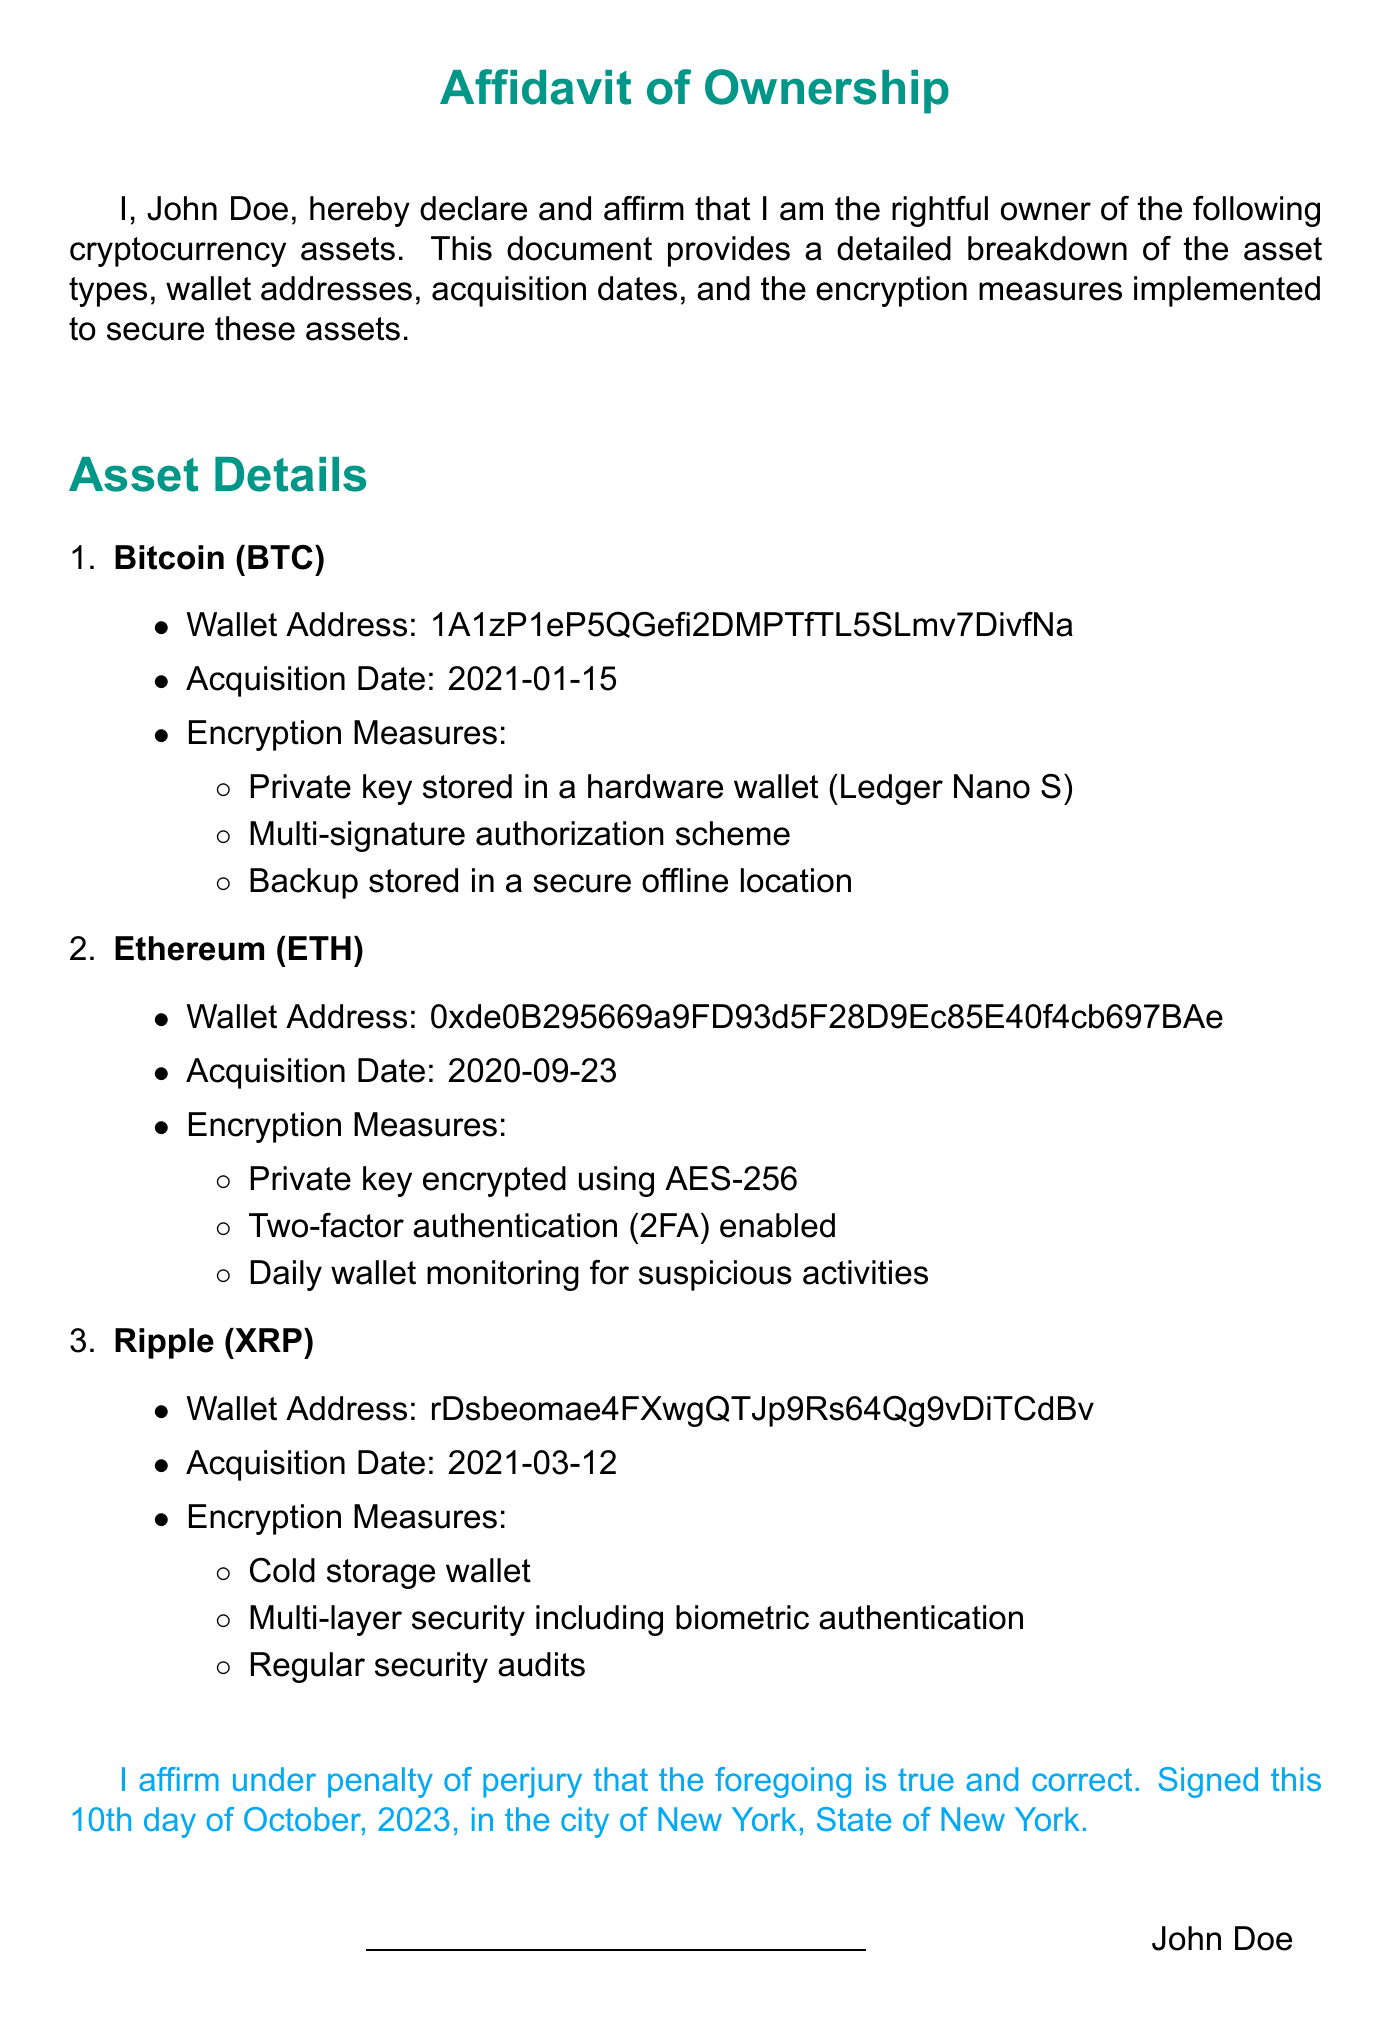What is the name of the owner? The owner's name is stated at the beginning of the document as "John Doe."
Answer: John Doe What cryptocurrency asset was acquired on 2021-01-15? This date corresponds to the acquisition of Bitcoin, as indicated in the asset details.
Answer: Bitcoin (BTC) What is the wallet address for Ethereum? The document specifies the Ethereum wallet address in the asset details section.
Answer: 0xde0B295669a9FD93d5F28D9Ec85E40f4cb697BAe What encryption measure is used for Bitcoin? The document lists several encryption measures for Bitcoin in the respective section, including the private key stored in a hardware wallet.
Answer: Private key stored in a hardware wallet (Ledger Nano S) How many cryptocurrency assets are mentioned in the affidavit? The document outlines a total of three different cryptocurrency assets that the owner claims to possess.
Answer: Three Is two-factor authentication enabled for Ethereum? This specifies a security measure for the Ethereum assets outlined in the affidavit.
Answer: Yes On what date was the affidavit signed? The document states the signing date at the bottom, before the owner's signature.
Answer: October 10, 2023 What type of wallet is used for Ripple? The affidavit describes the method of securing the Ripple assets, which is identified as a specific type of wallet.
Answer: Cold storage wallet What security measure includes biometric authentication? This question relates to the encryption measures listed for Ripple in the affidavit.
Answer: Multi-layer security including biometric authentication 